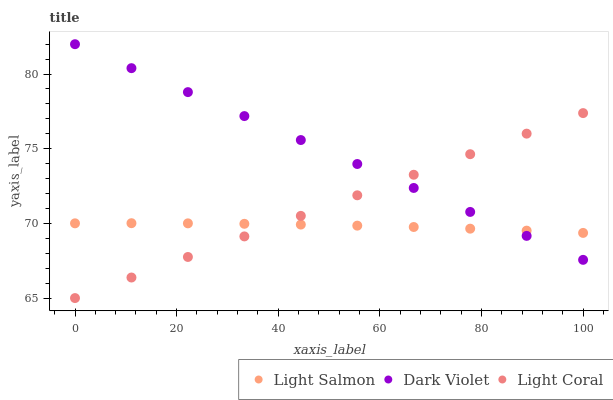Does Light Salmon have the minimum area under the curve?
Answer yes or no. Yes. Does Dark Violet have the maximum area under the curve?
Answer yes or no. Yes. Does Dark Violet have the minimum area under the curve?
Answer yes or no. No. Does Light Salmon have the maximum area under the curve?
Answer yes or no. No. Is Light Coral the smoothest?
Answer yes or no. Yes. Is Light Salmon the roughest?
Answer yes or no. Yes. Is Dark Violet the smoothest?
Answer yes or no. No. Is Dark Violet the roughest?
Answer yes or no. No. Does Light Coral have the lowest value?
Answer yes or no. Yes. Does Dark Violet have the lowest value?
Answer yes or no. No. Does Dark Violet have the highest value?
Answer yes or no. Yes. Does Light Salmon have the highest value?
Answer yes or no. No. Does Dark Violet intersect Light Salmon?
Answer yes or no. Yes. Is Dark Violet less than Light Salmon?
Answer yes or no. No. Is Dark Violet greater than Light Salmon?
Answer yes or no. No. 